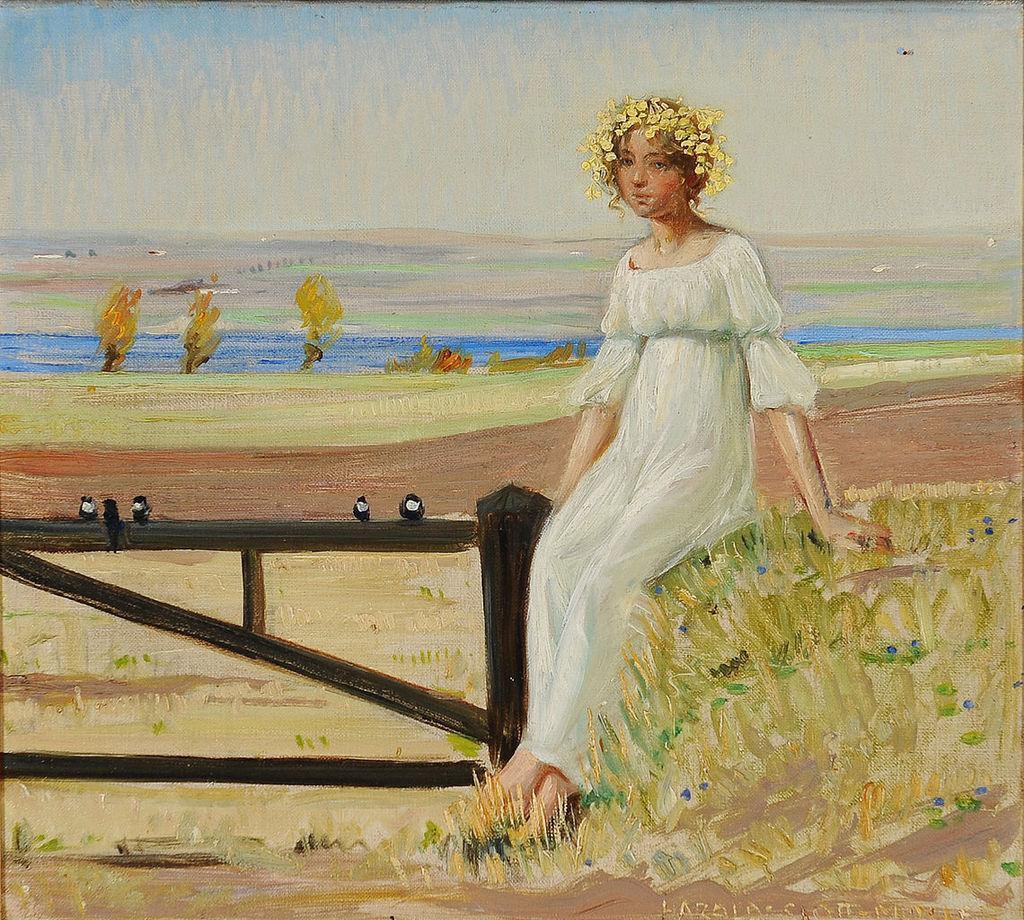Please provide a concise description of this image. In this picture I can observe painting of a woman. This woman is sitting, wearing white color dress. Beside her there is a wooden railing. I can observe some birds on the railing. In the background there are some plants. I can observe lake. There is a sky in the background. 